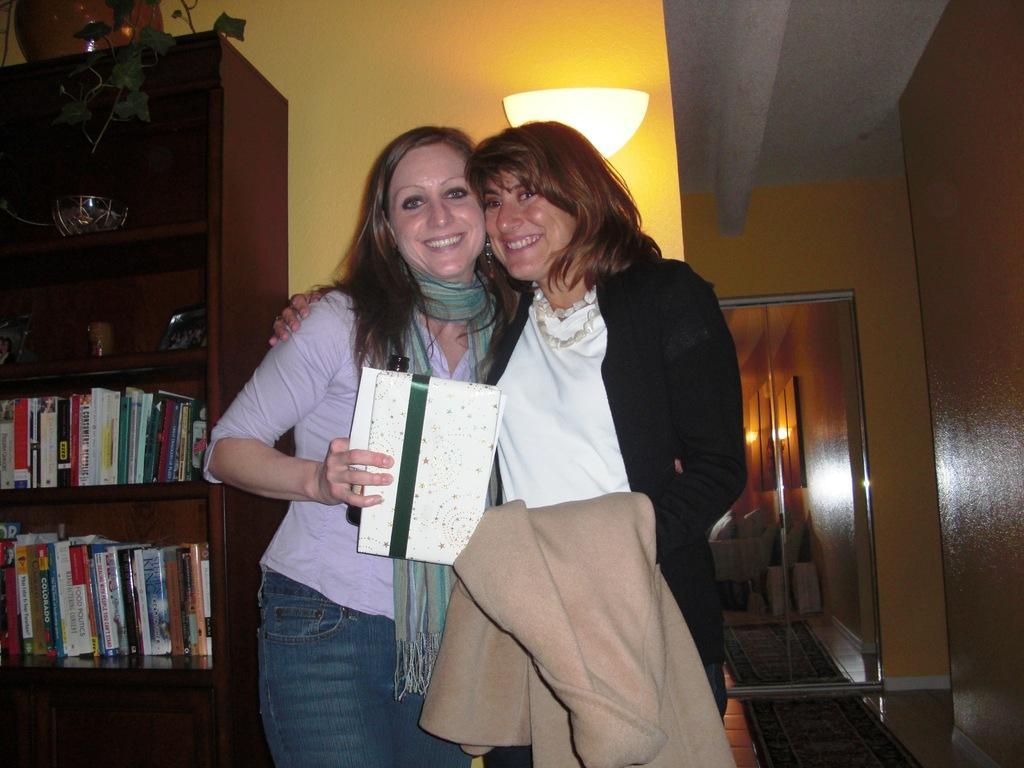Can you describe this image briefly? In this image we can see two women standing on the floor holding a box and a jacket. On the left side we can see some books, bowl, cup, plant and a photo frame in the shelves of a cupboard. On the backside we can see a wall, ceiling light, roof and a door. 